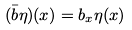<formula> <loc_0><loc_0><loc_500><loc_500>( { \bar { b } } \eta ) ( x ) = b _ { x } \eta ( x )</formula> 